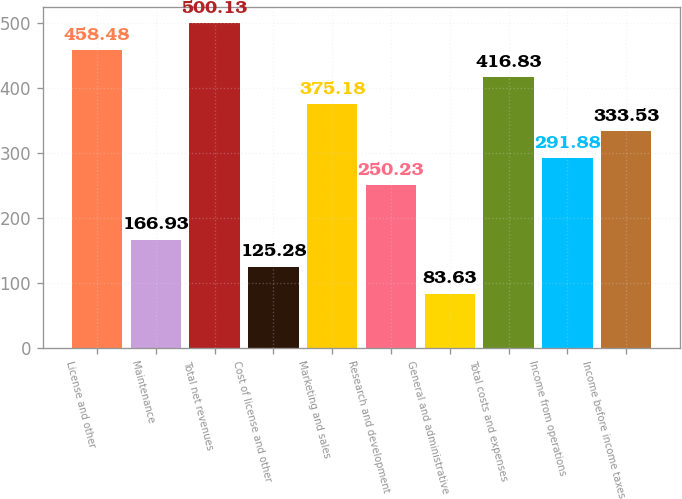Convert chart. <chart><loc_0><loc_0><loc_500><loc_500><bar_chart><fcel>License and other<fcel>Maintenance<fcel>Total net revenues<fcel>Cost of license and other<fcel>Marketing and sales<fcel>Research and development<fcel>General and administrative<fcel>Total costs and expenses<fcel>Income from operations<fcel>Income before income taxes<nl><fcel>458.48<fcel>166.93<fcel>500.13<fcel>125.28<fcel>375.18<fcel>250.23<fcel>83.63<fcel>416.83<fcel>291.88<fcel>333.53<nl></chart> 